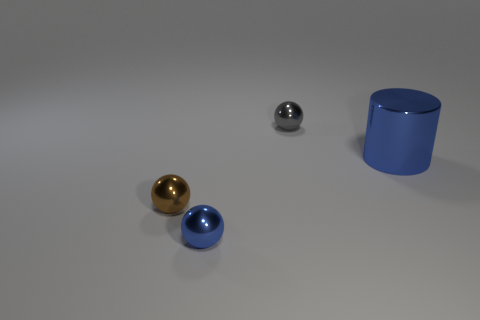There is a big blue metal thing; is its shape the same as the blue shiny thing that is on the left side of the large blue cylinder?
Your answer should be very brief. No. Are there any small metal spheres left of the small gray shiny object?
Provide a short and direct response. Yes. What is the material of the ball that is the same color as the cylinder?
Your response must be concise. Metal. There is a gray metallic sphere; is it the same size as the object right of the gray object?
Ensure brevity in your answer.  No. Are there any other large matte cylinders of the same color as the cylinder?
Provide a succinct answer. No. Are there any other tiny metallic objects that have the same shape as the brown metallic object?
Give a very brief answer. Yes. What shape is the small thing that is on the right side of the small brown thing and in front of the gray metallic thing?
Your response must be concise. Sphere. How many purple spheres are the same material as the blue cylinder?
Ensure brevity in your answer.  0. Is the number of objects that are in front of the large blue metallic cylinder less than the number of large yellow cubes?
Your answer should be very brief. No. Are there any tiny things that are behind the tiny shiny thing that is in front of the brown object?
Offer a terse response. Yes. 